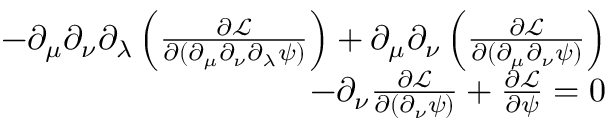Convert formula to latex. <formula><loc_0><loc_0><loc_500><loc_500>\begin{array} { r } { - \partial _ { \mu } \partial _ { \nu } \partial _ { \lambda } \left ( \frac { \partial \mathcal { L } } { \partial ( \partial _ { \mu } \partial _ { \nu } \partial _ { \lambda } \psi ) } \right ) + \partial _ { \mu } \partial _ { \nu } \left ( \frac { \partial \mathcal { L } } { \partial ( \partial _ { \mu } \partial _ { \nu } \psi ) } \right ) } \\ { - \partial _ { \nu } \frac { \partial \mathcal { L } } { \partial ( \partial _ { \nu } \psi ) } + \frac { \partial \mathcal { L } } { \partial \psi } = 0 } \end{array}</formula> 